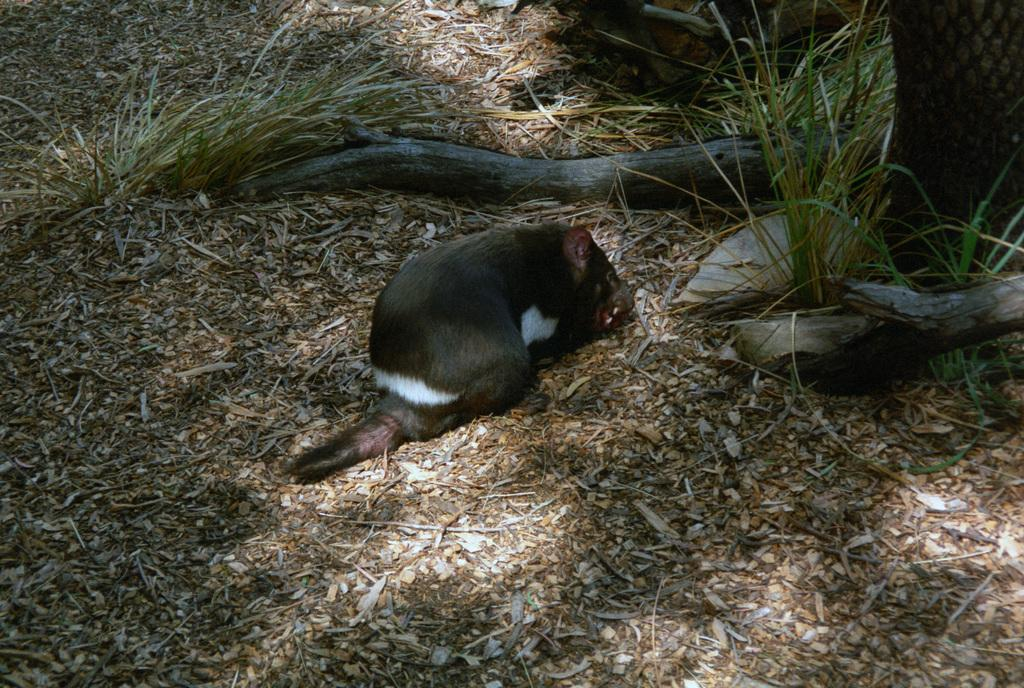What animal can be seen on the ground in the image? There is a mouse on the ground in the image. What type of environment is visible in the background of the image? There is grass, wood, and plants in the background of the image. When was the image taken? The image was taken during the day. What color is the flesh of the orange in the image? There is no orange present in the image, so it is not possible to determine the color of its flesh. 